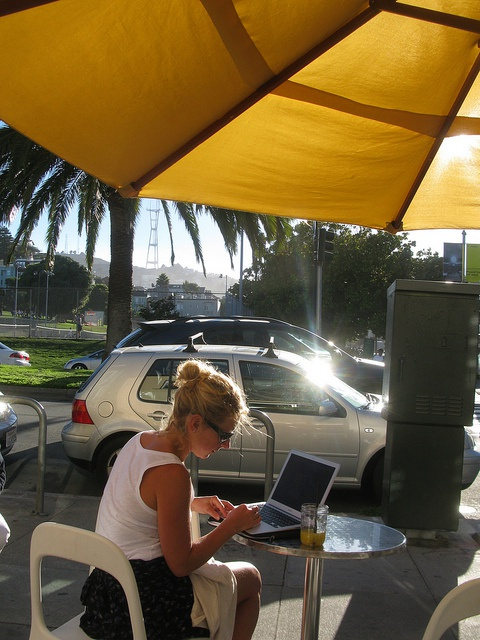Describe the objects in this image and their specific colors. I can see umbrella in black, olive, orange, and maroon tones, people in black, maroon, and darkgray tones, car in black, gray, and darkgray tones, chair in black and gray tones, and car in black, gray, white, and darkgray tones in this image. 